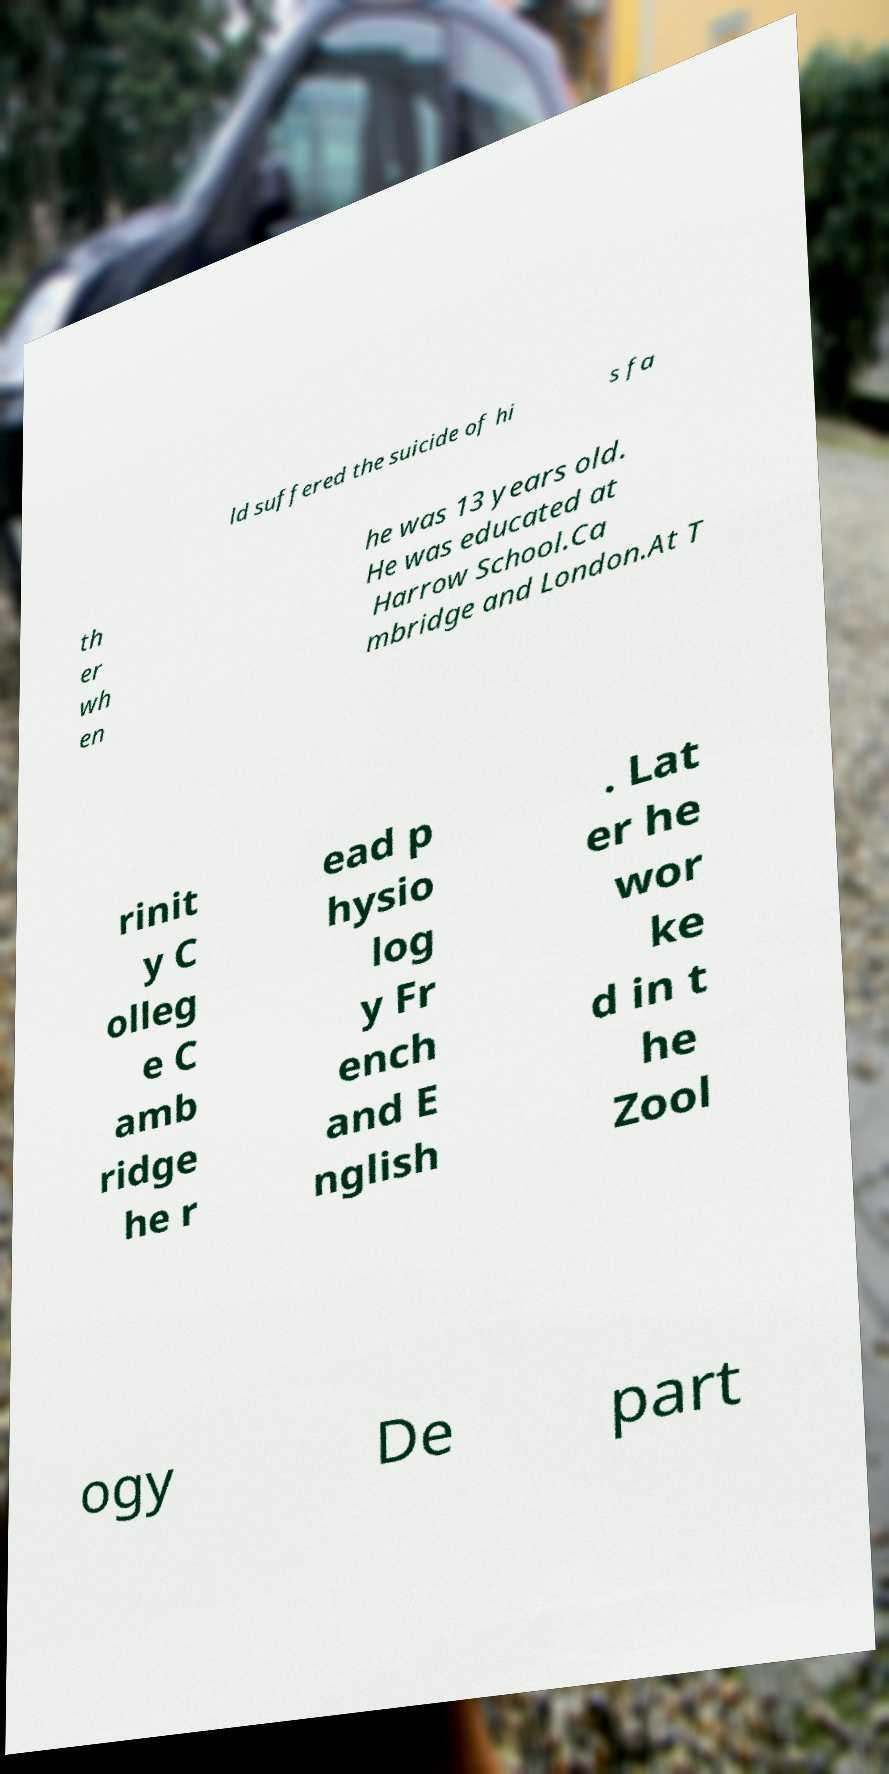Can you read and provide the text displayed in the image?This photo seems to have some interesting text. Can you extract and type it out for me? ld suffered the suicide of hi s fa th er wh en he was 13 years old. He was educated at Harrow School.Ca mbridge and London.At T rinit y C olleg e C amb ridge he r ead p hysio log y Fr ench and E nglish . Lat er he wor ke d in t he Zool ogy De part 